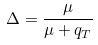Convert formula to latex. <formula><loc_0><loc_0><loc_500><loc_500>\Delta = \frac { \mu } { \mu + q _ { T } }</formula> 